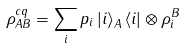Convert formula to latex. <formula><loc_0><loc_0><loc_500><loc_500>\rho ^ { c q } _ { A B } = \sum _ { i } p _ { i } \left | i \right \rangle _ { A } \left \langle i \right | \otimes \rho _ { i } ^ { B }</formula> 